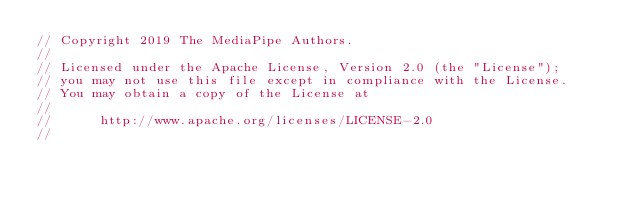<code> <loc_0><loc_0><loc_500><loc_500><_ObjectiveC_>// Copyright 2019 The MediaPipe Authors.
//
// Licensed under the Apache License, Version 2.0 (the "License");
// you may not use this file except in compliance with the License.
// You may obtain a copy of the License at
//
//      http://www.apache.org/licenses/LICENSE-2.0
//</code> 